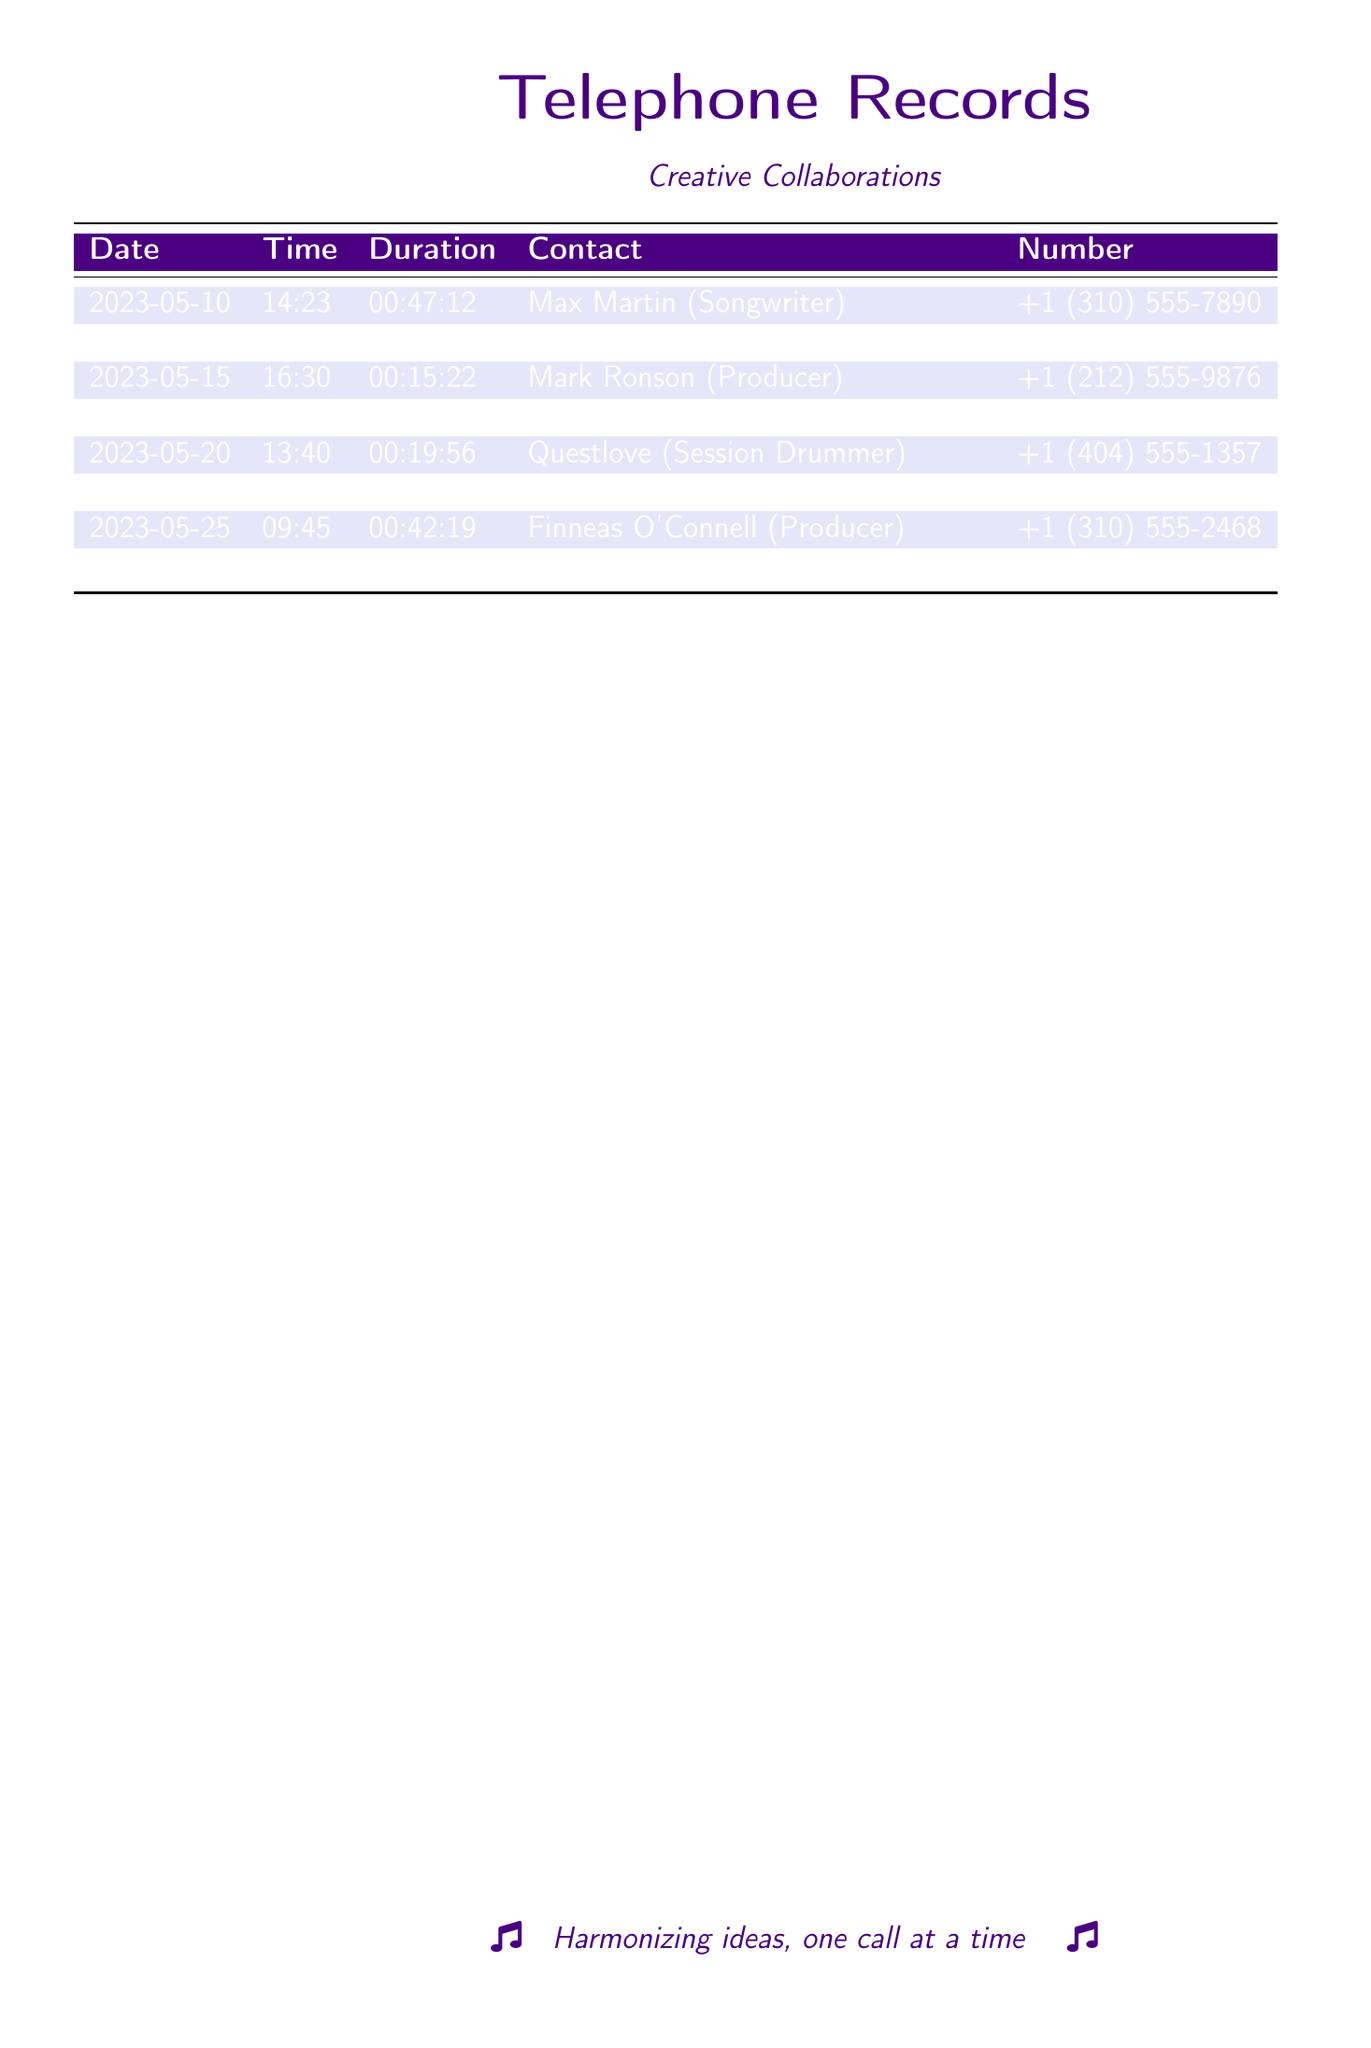What is the longest call duration? The longest call duration is the maximum duration listed in the records, which is 00:47:12 from a call with Max Martin.
Answer: 00:47:12 Who called Questlove? The record shows that on 2023-05-20, the person who called Questlove was the singer-songwriter.
Answer: singer-songwriter How many calls were made to songwriters? By counting the contacts identified as songwriters, there are five calls made to songwriters listed in the document.
Answer: 5 What date was the call with Sia Furler? The specific date of the call with Sia Furler is shown in the records, which is 2023-05-18.
Answer: 2023-05-18 Who is the contact with the number +1 (615) 555-3456? This number corresponds to the contact listed in the records as Julia Michaels, a songwriter.
Answer: Julia Michaels What type of professionals are frequently contacted in this document? The document lists songwriters, producers, and session musicians as the types of professionals contacted.
Answer: songwriters, producers, session musicians On what date did the call to Ryan Tedder occur? The records clearly indicate that the call to Ryan Tedder happened on 2023-05-22.
Answer: 2023-05-22 How many different contacts are listed in the records? The total count of different contacts is derived by counting each unique individual listed in the document, which totals eight distinct contacts.
Answer: 8 